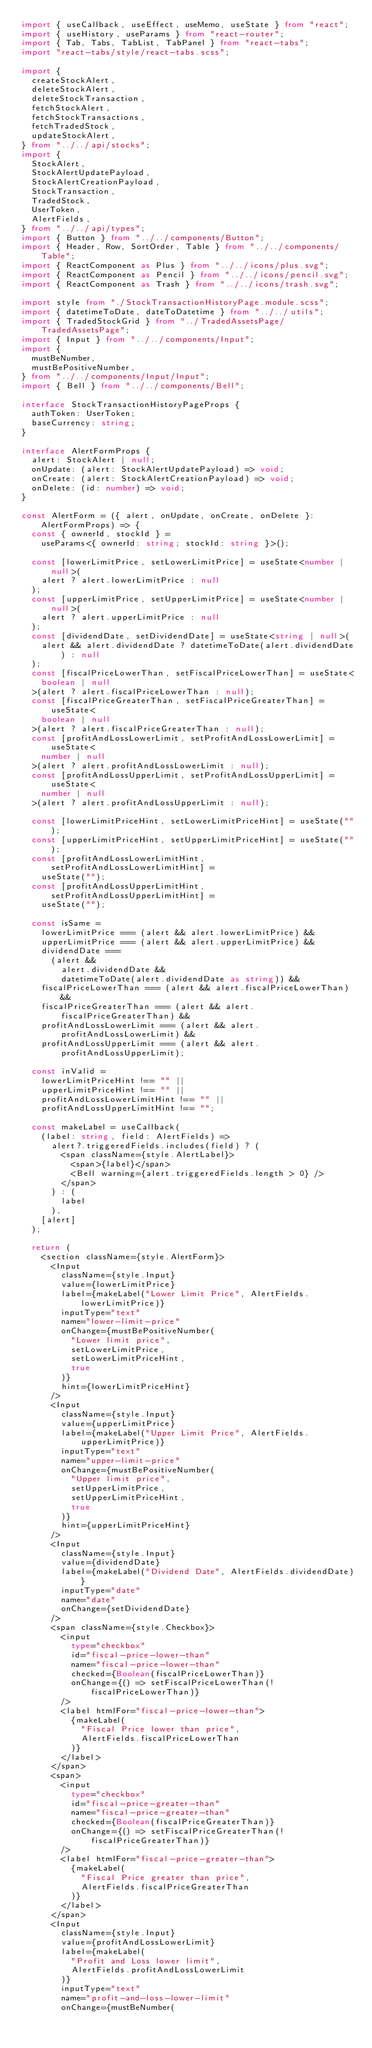Convert code to text. <code><loc_0><loc_0><loc_500><loc_500><_TypeScript_>import { useCallback, useEffect, useMemo, useState } from "react";
import { useHistory, useParams } from "react-router";
import { Tab, Tabs, TabList, TabPanel } from "react-tabs";
import "react-tabs/style/react-tabs.scss";

import {
  createStockAlert,
  deleteStockAlert,
  deleteStockTransaction,
  fetchStockAlert,
  fetchStockTransactions,
  fetchTradedStock,
  updateStockAlert,
} from "../../api/stocks";
import {
  StockAlert,
  StockAlertUpdatePayload,
  StockAlertCreationPayload,
  StockTransaction,
  TradedStock,
  UserToken,
  AlertFields,
} from "../../api/types";
import { Button } from "../../components/Button";
import { Header, Row, SortOrder, Table } from "../../components/Table";
import { ReactComponent as Plus } from "../../icons/plus.svg";
import { ReactComponent as Pencil } from "../../icons/pencil.svg";
import { ReactComponent as Trash } from "../../icons/trash.svg";

import style from "./StockTransactionHistoryPage.module.scss";
import { datetimeToDate, dateToDatetime } from "../../utils";
import { TradedStockGrid } from "../TradedAssetsPage/TradedAssetsPage";
import { Input } from "../../components/Input";
import {
  mustBeNumber,
  mustBePositiveNumber,
} from "../../components/Input/Input";
import { Bell } from "../../components/Bell";

interface StockTransactionHistoryPageProps {
  authToken: UserToken;
  baseCurrency: string;
}

interface AlertFormProps {
  alert: StockAlert | null;
  onUpdate: (alert: StockAlertUpdatePayload) => void;
  onCreate: (alert: StockAlertCreationPayload) => void;
  onDelete: (id: number) => void;
}

const AlertForm = ({ alert, onUpdate, onCreate, onDelete }: AlertFormProps) => {
  const { ownerId, stockId } =
    useParams<{ ownerId: string; stockId: string }>();

  const [lowerLimitPrice, setLowerLimitPrice] = useState<number | null>(
    alert ? alert.lowerLimitPrice : null
  );
  const [upperLimitPrice, setUpperLimitPrice] = useState<number | null>(
    alert ? alert.upperLimitPrice : null
  );
  const [dividendDate, setDividendDate] = useState<string | null>(
    alert && alert.dividendDate ? datetimeToDate(alert.dividendDate) : null
  );
  const [fiscalPriceLowerThan, setFiscalPriceLowerThan] = useState<
    boolean | null
  >(alert ? alert.fiscalPriceLowerThan : null);
  const [fiscalPriceGreaterThan, setFiscalPriceGreaterThan] = useState<
    boolean | null
  >(alert ? alert.fiscalPriceGreaterThan : null);
  const [profitAndLossLowerLimit, setProfitAndLossLowerLimit] = useState<
    number | null
  >(alert ? alert.profitAndLossLowerLimit : null);
  const [profitAndLossUpperLimit, setProfitAndLossUpperLimit] = useState<
    number | null
  >(alert ? alert.profitAndLossUpperLimit : null);

  const [lowerLimitPriceHint, setLowerLimitPriceHint] = useState("");
  const [upperLimitPriceHint, setUpperLimitPriceHint] = useState("");
  const [profitAndLossLowerLimitHint, setProfitAndLossLowerLimitHint] =
    useState("");
  const [profitAndLossUpperLimitHint, setProfitAndLossUpperLimitHint] =
    useState("");

  const isSame =
    lowerLimitPrice === (alert && alert.lowerLimitPrice) &&
    upperLimitPrice === (alert && alert.upperLimitPrice) &&
    dividendDate ===
      (alert &&
        alert.dividendDate &&
        datetimeToDate(alert.dividendDate as string)) &&
    fiscalPriceLowerThan === (alert && alert.fiscalPriceLowerThan) &&
    fiscalPriceGreaterThan === (alert && alert.fiscalPriceGreaterThan) &&
    profitAndLossLowerLimit === (alert && alert.profitAndLossLowerLimit) &&
    profitAndLossUpperLimit === (alert && alert.profitAndLossUpperLimit);

  const inValid =
    lowerLimitPriceHint !== "" ||
    upperLimitPriceHint !== "" ||
    profitAndLossLowerLimitHint !== "" ||
    profitAndLossUpperLimitHint !== "";

  const makeLabel = useCallback(
    (label: string, field: AlertFields) =>
      alert?.triggeredFields.includes(field) ? (
        <span className={style.AlertLabel}>
          <span>{label}</span>
          <Bell warning={alert.triggeredFields.length > 0} />
        </span>
      ) : (
        label
      ),
    [alert]
  );

  return (
    <section className={style.AlertForm}>
      <Input
        className={style.Input}
        value={lowerLimitPrice}
        label={makeLabel("Lower Limit Price", AlertFields.lowerLimitPrice)}
        inputType="text"
        name="lower-limit-price"
        onChange={mustBePositiveNumber(
          "Lower limit price",
          setLowerLimitPrice,
          setLowerLimitPriceHint,
          true
        )}
        hint={lowerLimitPriceHint}
      />
      <Input
        className={style.Input}
        value={upperLimitPrice}
        label={makeLabel("Upper Limit Price", AlertFields.upperLimitPrice)}
        inputType="text"
        name="upper-limit-price"
        onChange={mustBePositiveNumber(
          "Upper limit price",
          setUpperLimitPrice,
          setUpperLimitPriceHint,
          true
        )}
        hint={upperLimitPriceHint}
      />
      <Input
        className={style.Input}
        value={dividendDate}
        label={makeLabel("Dividend Date", AlertFields.dividendDate)}
        inputType="date"
        name="date"
        onChange={setDividendDate}
      />
      <span className={style.Checkbox}>
        <input
          type="checkbox"
          id="fiscal-price-lower-than"
          name="fiscal-price-lower-than"
          checked={Boolean(fiscalPriceLowerThan)}
          onChange={() => setFiscalPriceLowerThan(!fiscalPriceLowerThan)}
        />
        <label htmlFor="fiscal-price-lower-than">
          {makeLabel(
            "Fiscal Price lower than price",
            AlertFields.fiscalPriceLowerThan
          )}
        </label>
      </span>
      <span>
        <input
          type="checkbox"
          id="fiscal-price-greater-than"
          name="fiscal-price-greater-than"
          checked={Boolean(fiscalPriceGreaterThan)}
          onChange={() => setFiscalPriceGreaterThan(!fiscalPriceGreaterThan)}
        />
        <label htmlFor="fiscal-price-greater-than">
          {makeLabel(
            "Fiscal Price greater than price",
            AlertFields.fiscalPriceGreaterThan
          )}
        </label>
      </span>
      <Input
        className={style.Input}
        value={profitAndLossLowerLimit}
        label={makeLabel(
          "Profit and Loss lower limit",
          AlertFields.profitAndLossLowerLimit
        )}
        inputType="text"
        name="profit-and-loss-lower-limit"
        onChange={mustBeNumber(</code> 